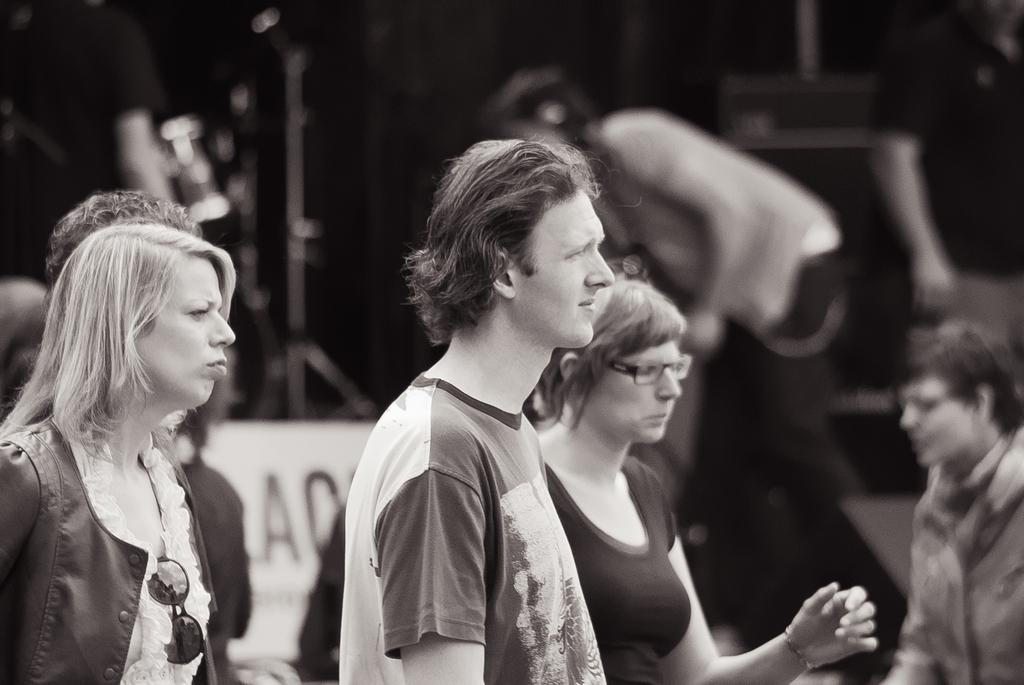What is the color scheme of the image? The image is black and white. What can be seen in the foreground of the image? There are people standing in front of the image. Are there any other people visible in the image? Yes, there are people behind the people standing in front. How is the background of the image depicted? The background of the image is blurred. What year is depicted in the image? The image does not depict a specific year; it is a black and white photograph with people standing in front and behind. Can you find a clover in the image? There is no clover present in the image. 